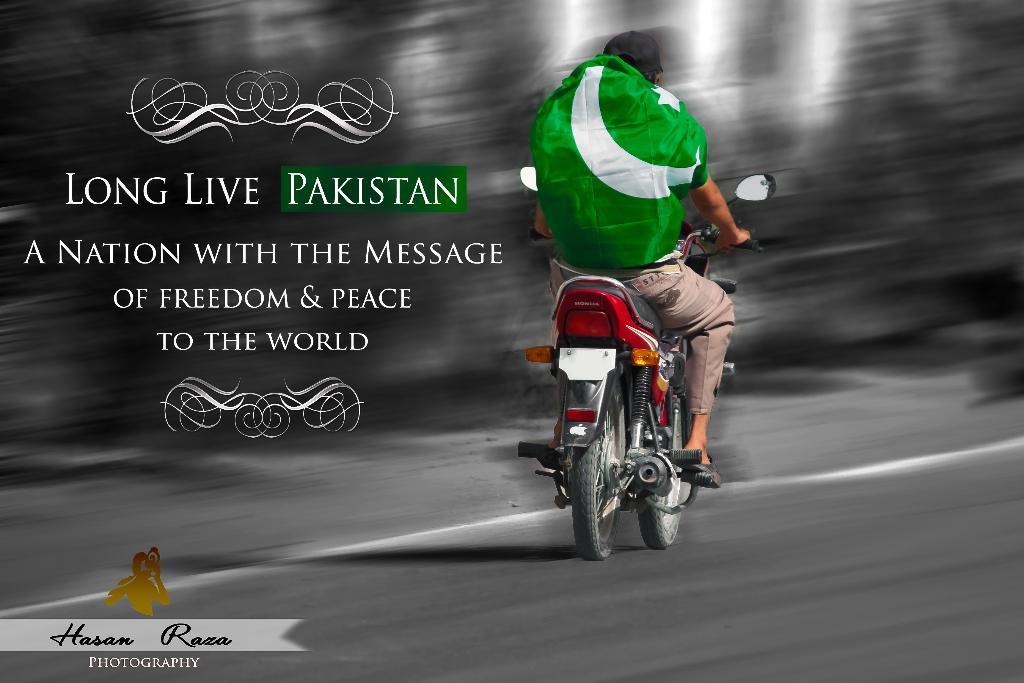Please provide a concise description of this image. This is an edited image where there is a bike and the person sitting on his bike. He is wearing a flag colour shirt. There is something written in this image that is long live Pakistan in Asian with the message of freedom and peace to the world and in the bottom left corner there is Hasan Raza photography. This bike has lights and mirror. 